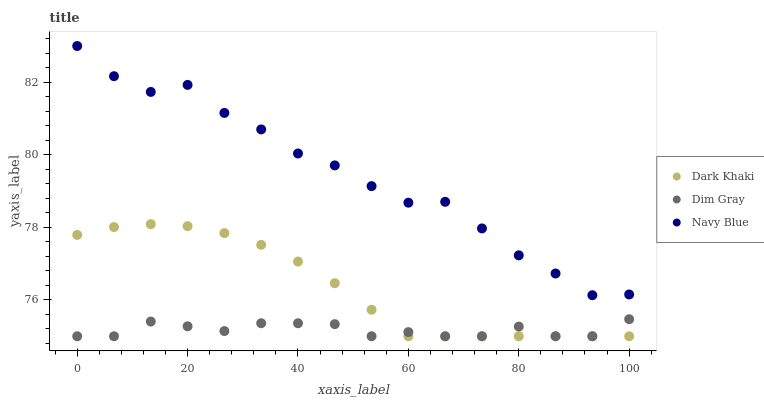Does Dim Gray have the minimum area under the curve?
Answer yes or no. Yes. Does Navy Blue have the maximum area under the curve?
Answer yes or no. Yes. Does Navy Blue have the minimum area under the curve?
Answer yes or no. No. Does Dim Gray have the maximum area under the curve?
Answer yes or no. No. Is Dark Khaki the smoothest?
Answer yes or no. Yes. Is Navy Blue the roughest?
Answer yes or no. Yes. Is Dim Gray the smoothest?
Answer yes or no. No. Is Dim Gray the roughest?
Answer yes or no. No. Does Dark Khaki have the lowest value?
Answer yes or no. Yes. Does Navy Blue have the lowest value?
Answer yes or no. No. Does Navy Blue have the highest value?
Answer yes or no. Yes. Does Dim Gray have the highest value?
Answer yes or no. No. Is Dark Khaki less than Navy Blue?
Answer yes or no. Yes. Is Navy Blue greater than Dim Gray?
Answer yes or no. Yes. Does Dark Khaki intersect Dim Gray?
Answer yes or no. Yes. Is Dark Khaki less than Dim Gray?
Answer yes or no. No. Is Dark Khaki greater than Dim Gray?
Answer yes or no. No. Does Dark Khaki intersect Navy Blue?
Answer yes or no. No. 